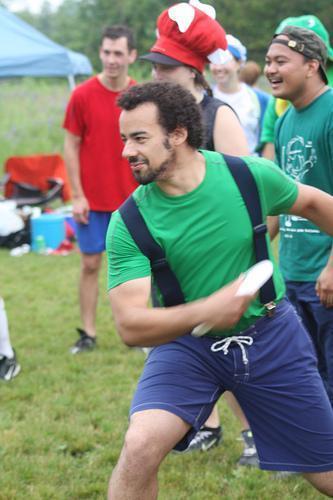How many frisbees are in the photo?
Give a very brief answer. 1. 